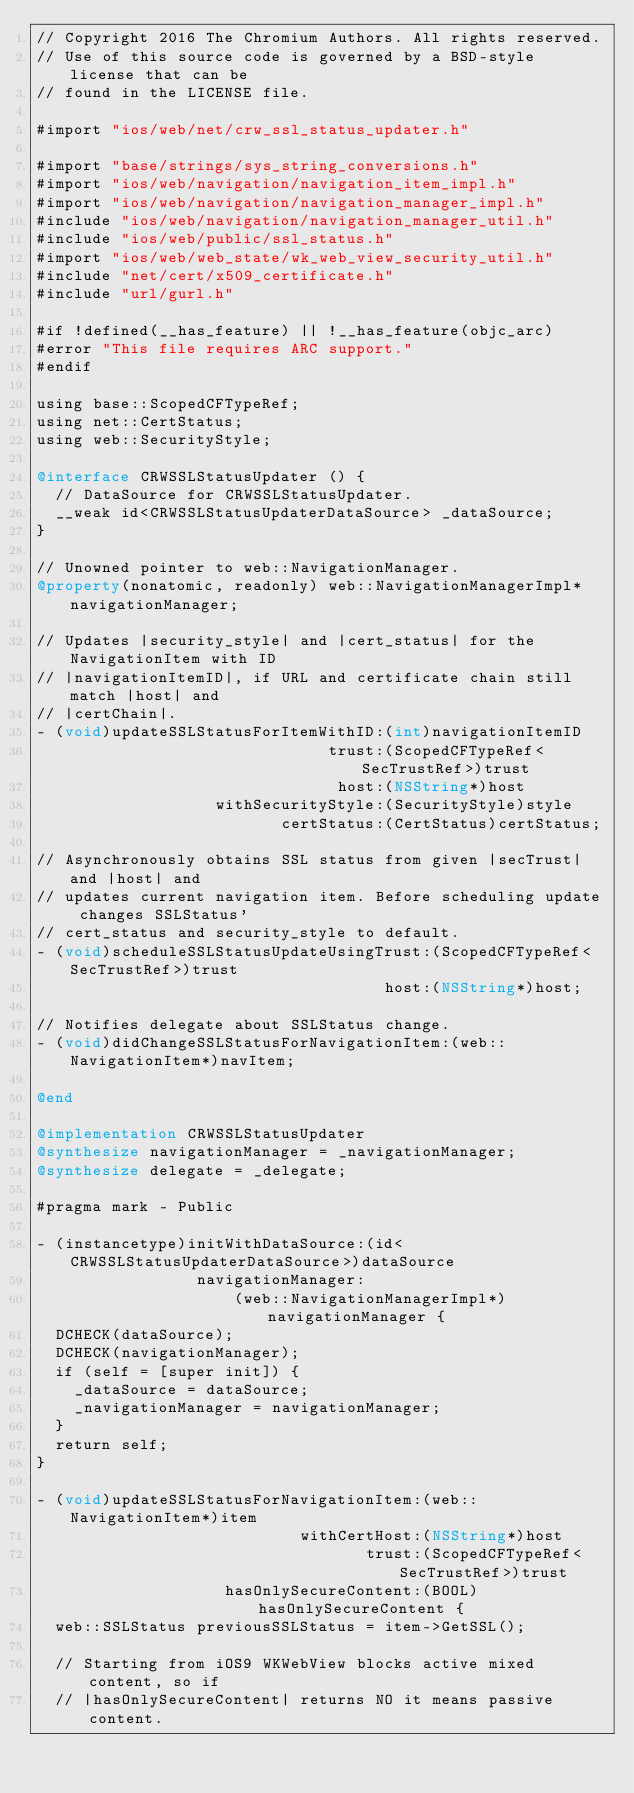Convert code to text. <code><loc_0><loc_0><loc_500><loc_500><_ObjectiveC_>// Copyright 2016 The Chromium Authors. All rights reserved.
// Use of this source code is governed by a BSD-style license that can be
// found in the LICENSE file.

#import "ios/web/net/crw_ssl_status_updater.h"

#import "base/strings/sys_string_conversions.h"
#import "ios/web/navigation/navigation_item_impl.h"
#import "ios/web/navigation/navigation_manager_impl.h"
#include "ios/web/navigation/navigation_manager_util.h"
#include "ios/web/public/ssl_status.h"
#import "ios/web/web_state/wk_web_view_security_util.h"
#include "net/cert/x509_certificate.h"
#include "url/gurl.h"

#if !defined(__has_feature) || !__has_feature(objc_arc)
#error "This file requires ARC support."
#endif

using base::ScopedCFTypeRef;
using net::CertStatus;
using web::SecurityStyle;

@interface CRWSSLStatusUpdater () {
  // DataSource for CRWSSLStatusUpdater.
  __weak id<CRWSSLStatusUpdaterDataSource> _dataSource;
}

// Unowned pointer to web::NavigationManager.
@property(nonatomic, readonly) web::NavigationManagerImpl* navigationManager;

// Updates |security_style| and |cert_status| for the NavigationItem with ID
// |navigationItemID|, if URL and certificate chain still match |host| and
// |certChain|.
- (void)updateSSLStatusForItemWithID:(int)navigationItemID
                               trust:(ScopedCFTypeRef<SecTrustRef>)trust
                                host:(NSString*)host
                   withSecurityStyle:(SecurityStyle)style
                          certStatus:(CertStatus)certStatus;

// Asynchronously obtains SSL status from given |secTrust| and |host| and
// updates current navigation item. Before scheduling update changes SSLStatus'
// cert_status and security_style to default.
- (void)scheduleSSLStatusUpdateUsingTrust:(ScopedCFTypeRef<SecTrustRef>)trust
                                     host:(NSString*)host;

// Notifies delegate about SSLStatus change.
- (void)didChangeSSLStatusForNavigationItem:(web::NavigationItem*)navItem;

@end

@implementation CRWSSLStatusUpdater
@synthesize navigationManager = _navigationManager;
@synthesize delegate = _delegate;

#pragma mark - Public

- (instancetype)initWithDataSource:(id<CRWSSLStatusUpdaterDataSource>)dataSource
                 navigationManager:
                     (web::NavigationManagerImpl*)navigationManager {
  DCHECK(dataSource);
  DCHECK(navigationManager);
  if (self = [super init]) {
    _dataSource = dataSource;
    _navigationManager = navigationManager;
  }
  return self;
}

- (void)updateSSLStatusForNavigationItem:(web::NavigationItem*)item
                            withCertHost:(NSString*)host
                                   trust:(ScopedCFTypeRef<SecTrustRef>)trust
                    hasOnlySecureContent:(BOOL)hasOnlySecureContent {
  web::SSLStatus previousSSLStatus = item->GetSSL();

  // Starting from iOS9 WKWebView blocks active mixed content, so if
  // |hasOnlySecureContent| returns NO it means passive content.</code> 